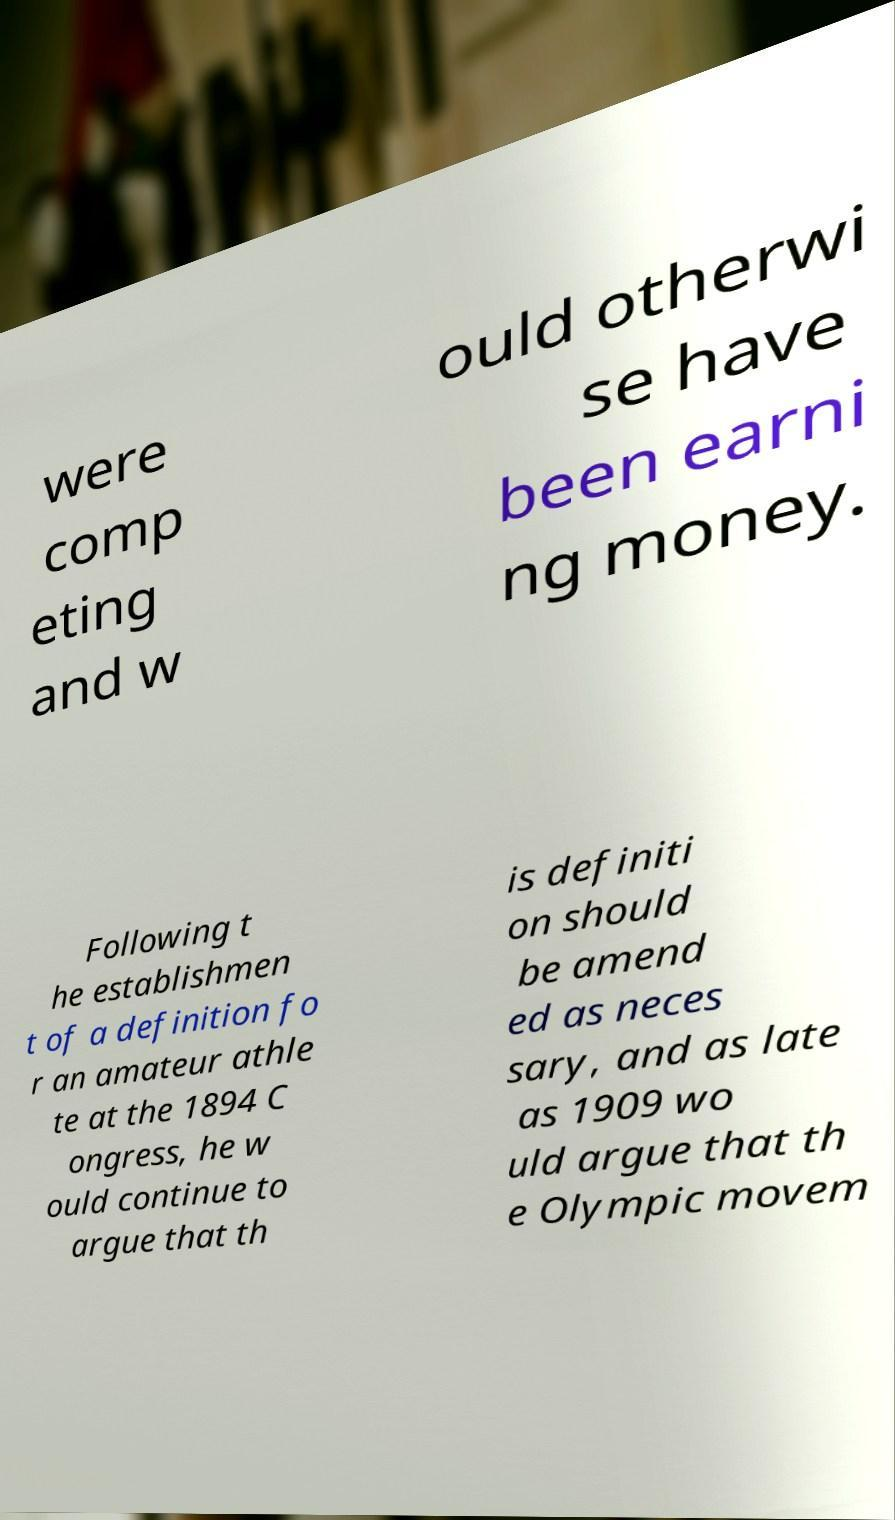Please identify and transcribe the text found in this image. were comp eting and w ould otherwi se have been earni ng money. Following t he establishmen t of a definition fo r an amateur athle te at the 1894 C ongress, he w ould continue to argue that th is definiti on should be amend ed as neces sary, and as late as 1909 wo uld argue that th e Olympic movem 